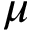Convert formula to latex. <formula><loc_0><loc_0><loc_500><loc_500>\mu</formula> 